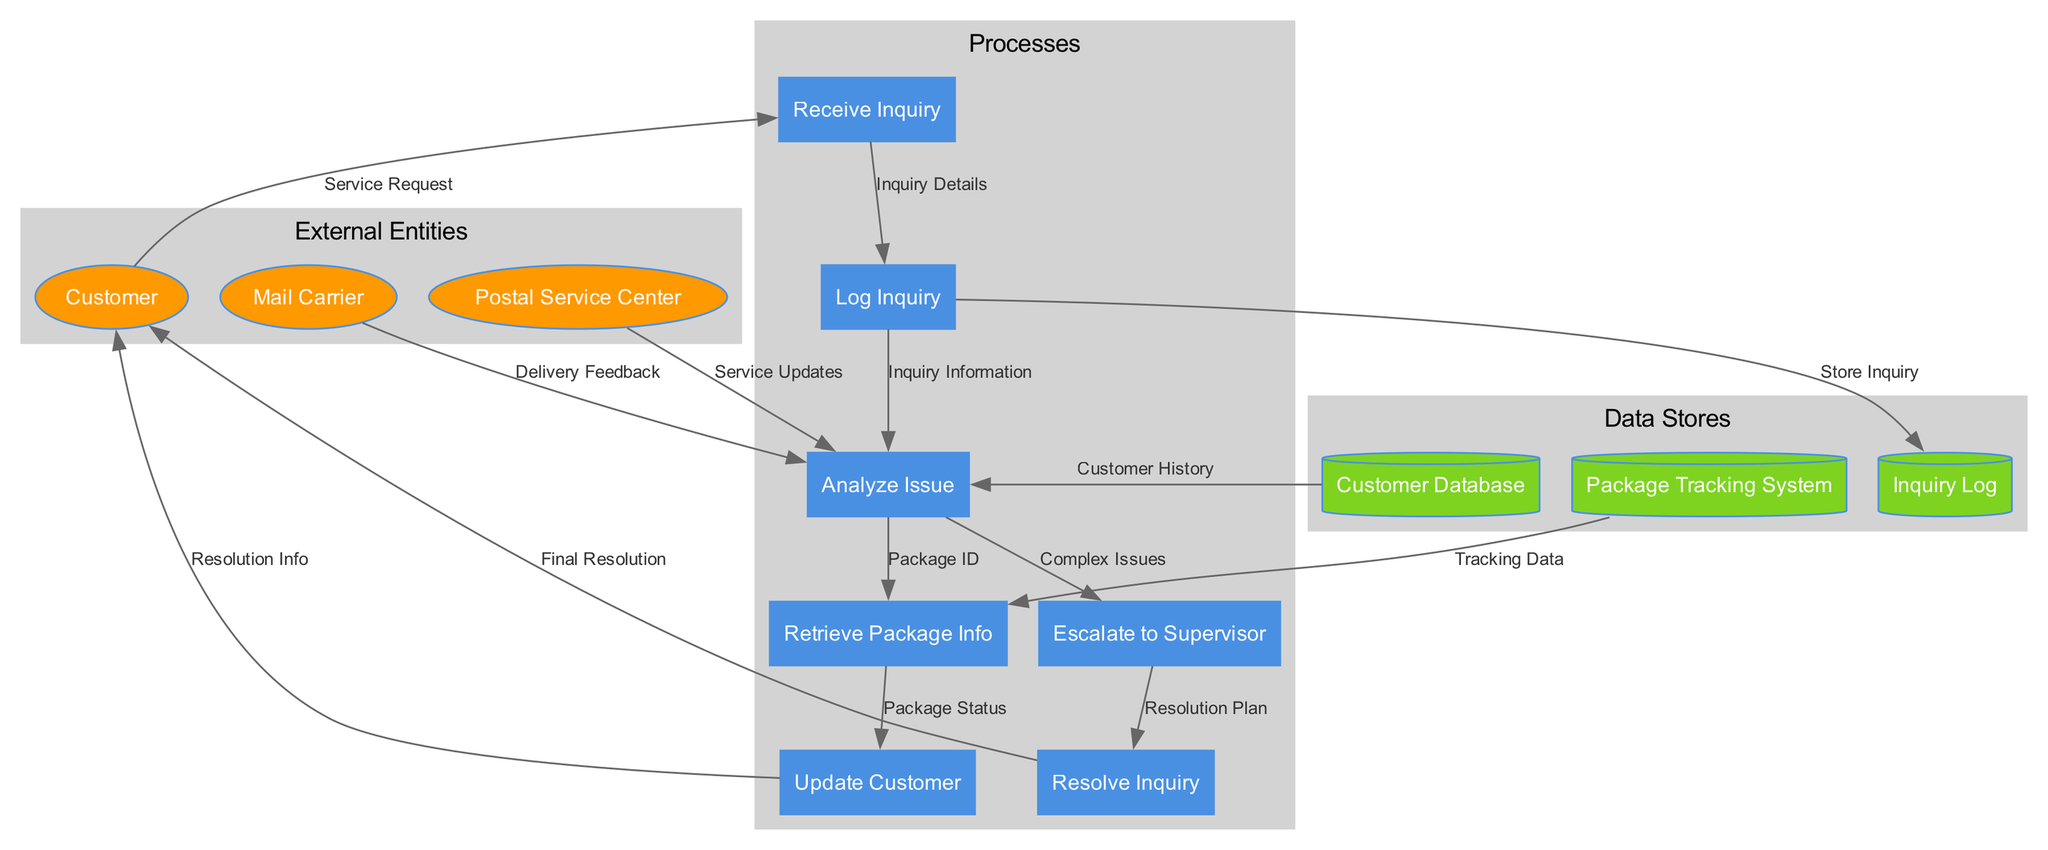What is the first process in the customer service inquiry handling? The diagram indicates that the first process is "Receive Inquiry" as it is the initial step where the service request from the customer is handled.
Answer: Receive Inquiry How many external entities are represented in the diagram? By counting the distinct external entities listed in the diagram, we see there are three: Customer, Postal Service Center, and Mail Carrier.
Answer: 3 Which data store is used to track inquiries? The data store labeled "Inquiry Log" is specifically designated for storing the details of inquiries logged in the process.
Answer: Inquiry Log What information flows from the "Update Customer" process to the "Customer"? The diagram shows that "Resolution Info" is the data flow from the "Update Customer" process to the "Customer", which provides the outcome of the inquiry resolution.
Answer: Resolution Info Which process is connected to both the "Customer Database" and "Postal Service Center"? The "Analyze Issue" process receives inputs from both the "Customer Database" and the "Postal Service Center", indicating it requires information from these sources to proceed with analysis.
Answer: Analyze Issue What happens when an inquiry is determined to be complex according to the diagram? The "Analyze Issue" process leads to the "Escalate to Supervisor" process when an issue is assessed as complex, indicating a need for higher-level intervention.
Answer: Escalate to Supervisor How many processes are involved in resolving a customer inquiry? The diagram outlines a total of seven processes involved in resolving a customer inquiry, starting from receiving the inquiry to final resolution.
Answer: 7 What data flow occurs after "Retrieve Package Info"? Following "Retrieve Package Info", the next data flow is to "Update Customer", indicating this process communicates the package status to the customer.
Answer: Update Customer Which roles provide feedback to the "Analyze Issue" process? The "Analyze Issue" process receives feedback from both the "Mail Carrier" (Delivery Feedback) and the "Postal Service Center" (Service Updates), which are crucial for analyzing the customer's issue.
Answer: Mail Carrier, Postal Service Center 